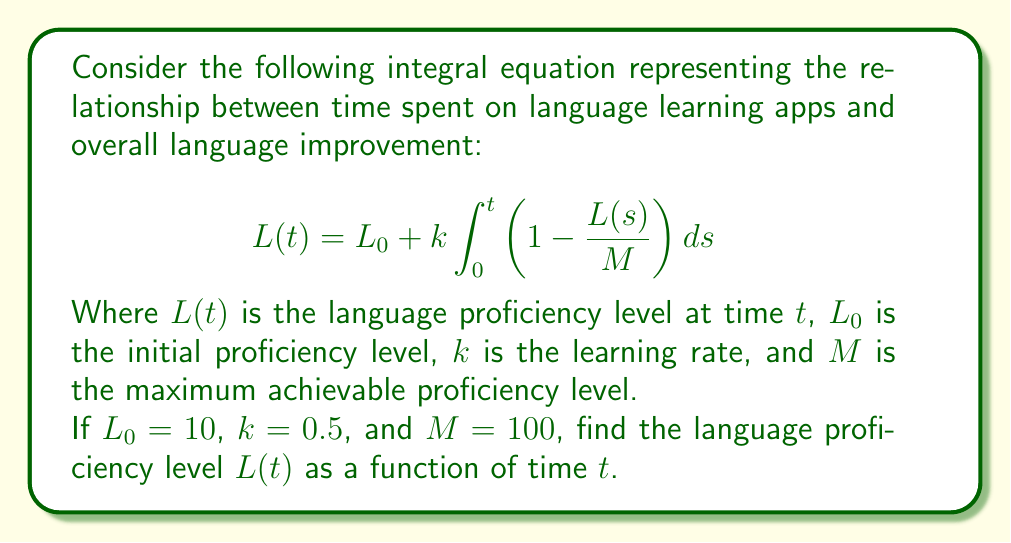Help me with this question. To solve this integral equation, we'll follow these steps:

1) First, we differentiate both sides of the equation with respect to $t$:

   $$\frac{dL}{dt} = k \left(1 - \frac{L(t)}{M}\right)$$

2) This is a separable differential equation. We can rewrite it as:

   $$\frac{dL}{1 - \frac{L}{M}} = k dt$$

3) Integrate both sides:

   $$\int \frac{dL}{1 - \frac{L}{M}} = \int k dt$$

4) The left side integrates to $-M \ln|1 - \frac{L}{M}|$, so we have:

   $$-M \ln\left|1 - \frac{L}{M}\right| = kt + C$$

5) Solve for $L$:

   $$1 - \frac{L}{M} = e^{-\frac{kt + C}{M}}$$
   $$L = M(1 - e^{-\frac{kt + C}{M}})$$

6) Use the initial condition $L(0) = L_0 = 10$ to find $C$:

   $$10 = 100(1 - e^{-\frac{C}{100}})$$
   $$e^{-\frac{C}{100}} = 0.9$$
   $$C = -100 \ln(0.9)$$

7) Substitute the values $k = 0.5$, $M = 100$, and $C = -100 \ln(0.9)$:

   $$L(t) = 100(1 - e^{-\frac{0.5t - 100 \ln(0.9)}{100}})$$
   $$L(t) = 100(1 - 0.9e^{-0.005t})$$

This is the final solution for $L(t)$.
Answer: $L(t) = 100(1 - 0.9e^{-0.005t})$ 